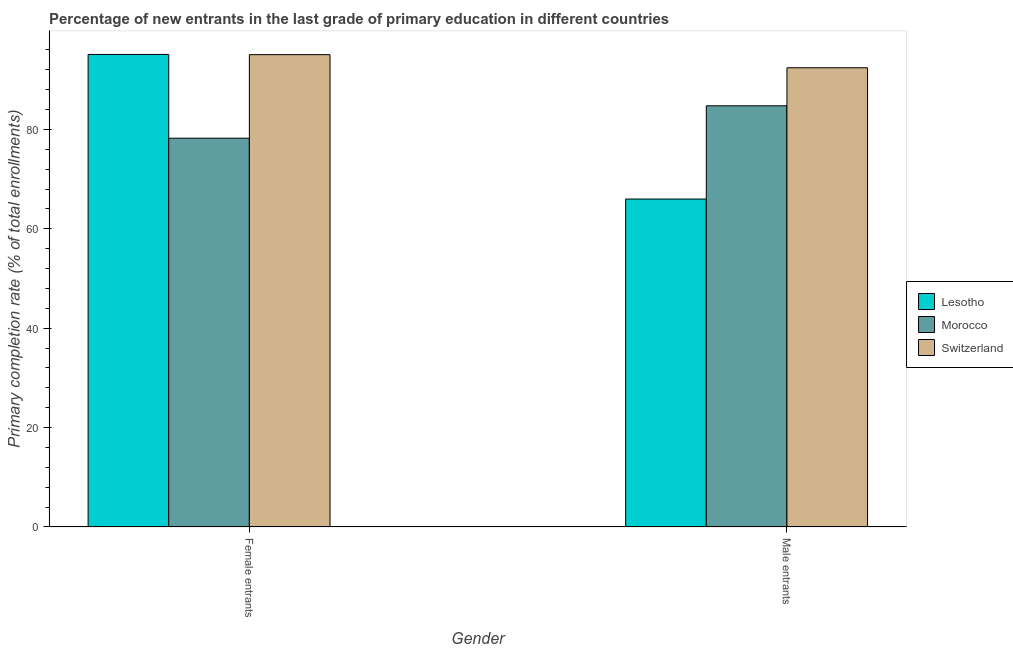How many groups of bars are there?
Offer a very short reply. 2. Are the number of bars on each tick of the X-axis equal?
Keep it short and to the point. Yes. How many bars are there on the 1st tick from the left?
Give a very brief answer. 3. How many bars are there on the 2nd tick from the right?
Your answer should be compact. 3. What is the label of the 1st group of bars from the left?
Provide a short and direct response. Female entrants. What is the primary completion rate of female entrants in Lesotho?
Ensure brevity in your answer.  95.1. Across all countries, what is the maximum primary completion rate of female entrants?
Make the answer very short. 95.1. Across all countries, what is the minimum primary completion rate of male entrants?
Give a very brief answer. 66. In which country was the primary completion rate of female entrants maximum?
Offer a terse response. Lesotho. In which country was the primary completion rate of female entrants minimum?
Provide a succinct answer. Morocco. What is the total primary completion rate of female entrants in the graph?
Ensure brevity in your answer.  268.4. What is the difference between the primary completion rate of female entrants in Morocco and that in Lesotho?
Provide a short and direct response. -16.86. What is the difference between the primary completion rate of female entrants in Switzerland and the primary completion rate of male entrants in Lesotho?
Make the answer very short. 29.06. What is the average primary completion rate of female entrants per country?
Ensure brevity in your answer.  89.47. What is the difference between the primary completion rate of male entrants and primary completion rate of female entrants in Morocco?
Your response must be concise. 6.52. What is the ratio of the primary completion rate of female entrants in Lesotho to that in Morocco?
Your answer should be compact. 1.22. Is the primary completion rate of female entrants in Switzerland less than that in Lesotho?
Provide a short and direct response. Yes. What does the 2nd bar from the left in Female entrants represents?
Your answer should be compact. Morocco. What does the 3rd bar from the right in Male entrants represents?
Keep it short and to the point. Lesotho. How many countries are there in the graph?
Provide a succinct answer. 3. Does the graph contain grids?
Your answer should be very brief. No. Where does the legend appear in the graph?
Keep it short and to the point. Center right. What is the title of the graph?
Your answer should be compact. Percentage of new entrants in the last grade of primary education in different countries. What is the label or title of the Y-axis?
Make the answer very short. Primary completion rate (% of total enrollments). What is the Primary completion rate (% of total enrollments) of Lesotho in Female entrants?
Provide a succinct answer. 95.1. What is the Primary completion rate (% of total enrollments) of Morocco in Female entrants?
Ensure brevity in your answer.  78.24. What is the Primary completion rate (% of total enrollments) in Switzerland in Female entrants?
Keep it short and to the point. 95.06. What is the Primary completion rate (% of total enrollments) in Lesotho in Male entrants?
Your answer should be very brief. 66. What is the Primary completion rate (% of total enrollments) in Morocco in Male entrants?
Keep it short and to the point. 84.76. What is the Primary completion rate (% of total enrollments) of Switzerland in Male entrants?
Provide a succinct answer. 92.42. Across all Gender, what is the maximum Primary completion rate (% of total enrollments) of Lesotho?
Provide a short and direct response. 95.1. Across all Gender, what is the maximum Primary completion rate (% of total enrollments) in Morocco?
Offer a very short reply. 84.76. Across all Gender, what is the maximum Primary completion rate (% of total enrollments) of Switzerland?
Your answer should be compact. 95.06. Across all Gender, what is the minimum Primary completion rate (% of total enrollments) of Lesotho?
Make the answer very short. 66. Across all Gender, what is the minimum Primary completion rate (% of total enrollments) in Morocco?
Give a very brief answer. 78.24. Across all Gender, what is the minimum Primary completion rate (% of total enrollments) in Switzerland?
Your answer should be very brief. 92.42. What is the total Primary completion rate (% of total enrollments) in Lesotho in the graph?
Give a very brief answer. 161.1. What is the total Primary completion rate (% of total enrollments) in Morocco in the graph?
Your response must be concise. 163.01. What is the total Primary completion rate (% of total enrollments) of Switzerland in the graph?
Make the answer very short. 187.48. What is the difference between the Primary completion rate (% of total enrollments) of Lesotho in Female entrants and that in Male entrants?
Make the answer very short. 29.1. What is the difference between the Primary completion rate (% of total enrollments) in Morocco in Female entrants and that in Male entrants?
Ensure brevity in your answer.  -6.52. What is the difference between the Primary completion rate (% of total enrollments) of Switzerland in Female entrants and that in Male entrants?
Offer a very short reply. 2.64. What is the difference between the Primary completion rate (% of total enrollments) in Lesotho in Female entrants and the Primary completion rate (% of total enrollments) in Morocco in Male entrants?
Make the answer very short. 10.34. What is the difference between the Primary completion rate (% of total enrollments) of Lesotho in Female entrants and the Primary completion rate (% of total enrollments) of Switzerland in Male entrants?
Give a very brief answer. 2.68. What is the difference between the Primary completion rate (% of total enrollments) in Morocco in Female entrants and the Primary completion rate (% of total enrollments) in Switzerland in Male entrants?
Offer a terse response. -14.18. What is the average Primary completion rate (% of total enrollments) of Lesotho per Gender?
Keep it short and to the point. 80.55. What is the average Primary completion rate (% of total enrollments) in Morocco per Gender?
Offer a terse response. 81.5. What is the average Primary completion rate (% of total enrollments) of Switzerland per Gender?
Make the answer very short. 93.74. What is the difference between the Primary completion rate (% of total enrollments) of Lesotho and Primary completion rate (% of total enrollments) of Morocco in Female entrants?
Your response must be concise. 16.86. What is the difference between the Primary completion rate (% of total enrollments) of Lesotho and Primary completion rate (% of total enrollments) of Switzerland in Female entrants?
Offer a terse response. 0.04. What is the difference between the Primary completion rate (% of total enrollments) of Morocco and Primary completion rate (% of total enrollments) of Switzerland in Female entrants?
Provide a short and direct response. -16.82. What is the difference between the Primary completion rate (% of total enrollments) in Lesotho and Primary completion rate (% of total enrollments) in Morocco in Male entrants?
Your answer should be very brief. -18.76. What is the difference between the Primary completion rate (% of total enrollments) of Lesotho and Primary completion rate (% of total enrollments) of Switzerland in Male entrants?
Ensure brevity in your answer.  -26.42. What is the difference between the Primary completion rate (% of total enrollments) in Morocco and Primary completion rate (% of total enrollments) in Switzerland in Male entrants?
Keep it short and to the point. -7.66. What is the ratio of the Primary completion rate (% of total enrollments) in Lesotho in Female entrants to that in Male entrants?
Keep it short and to the point. 1.44. What is the ratio of the Primary completion rate (% of total enrollments) of Morocco in Female entrants to that in Male entrants?
Keep it short and to the point. 0.92. What is the ratio of the Primary completion rate (% of total enrollments) of Switzerland in Female entrants to that in Male entrants?
Offer a very short reply. 1.03. What is the difference between the highest and the second highest Primary completion rate (% of total enrollments) in Lesotho?
Your answer should be compact. 29.1. What is the difference between the highest and the second highest Primary completion rate (% of total enrollments) of Morocco?
Your response must be concise. 6.52. What is the difference between the highest and the second highest Primary completion rate (% of total enrollments) in Switzerland?
Give a very brief answer. 2.64. What is the difference between the highest and the lowest Primary completion rate (% of total enrollments) of Lesotho?
Keep it short and to the point. 29.1. What is the difference between the highest and the lowest Primary completion rate (% of total enrollments) of Morocco?
Keep it short and to the point. 6.52. What is the difference between the highest and the lowest Primary completion rate (% of total enrollments) in Switzerland?
Make the answer very short. 2.64. 